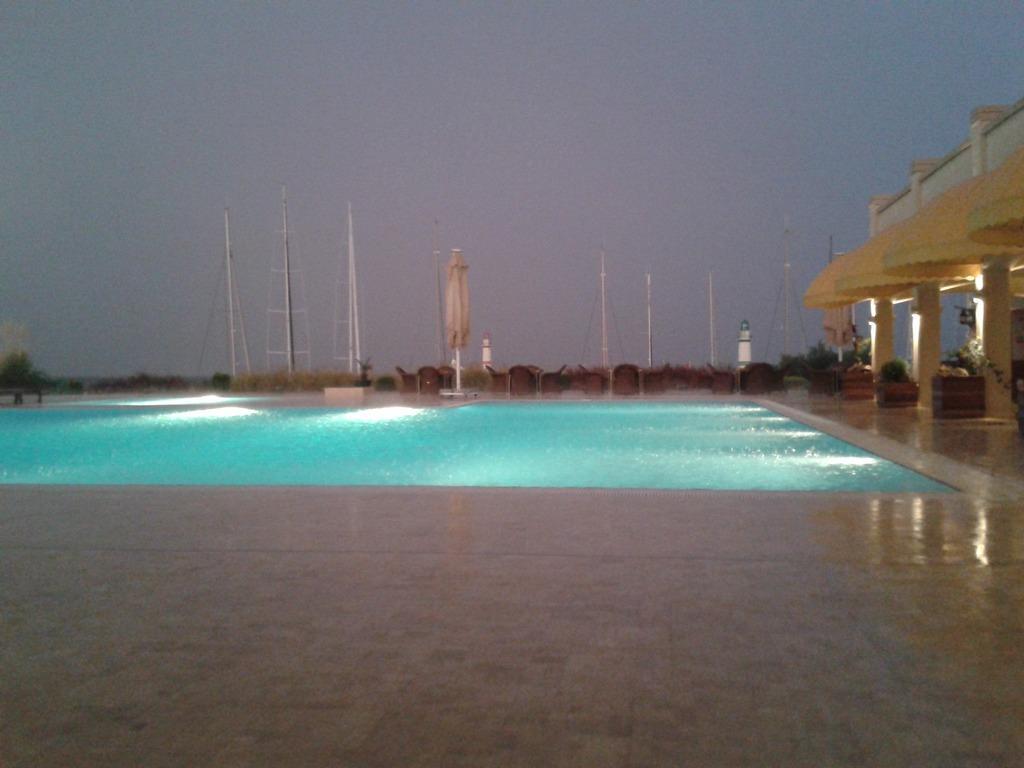Can you describe this image briefly? It looks like some resort, there is a swimming pool and behind the swimming pool there are few poles. 